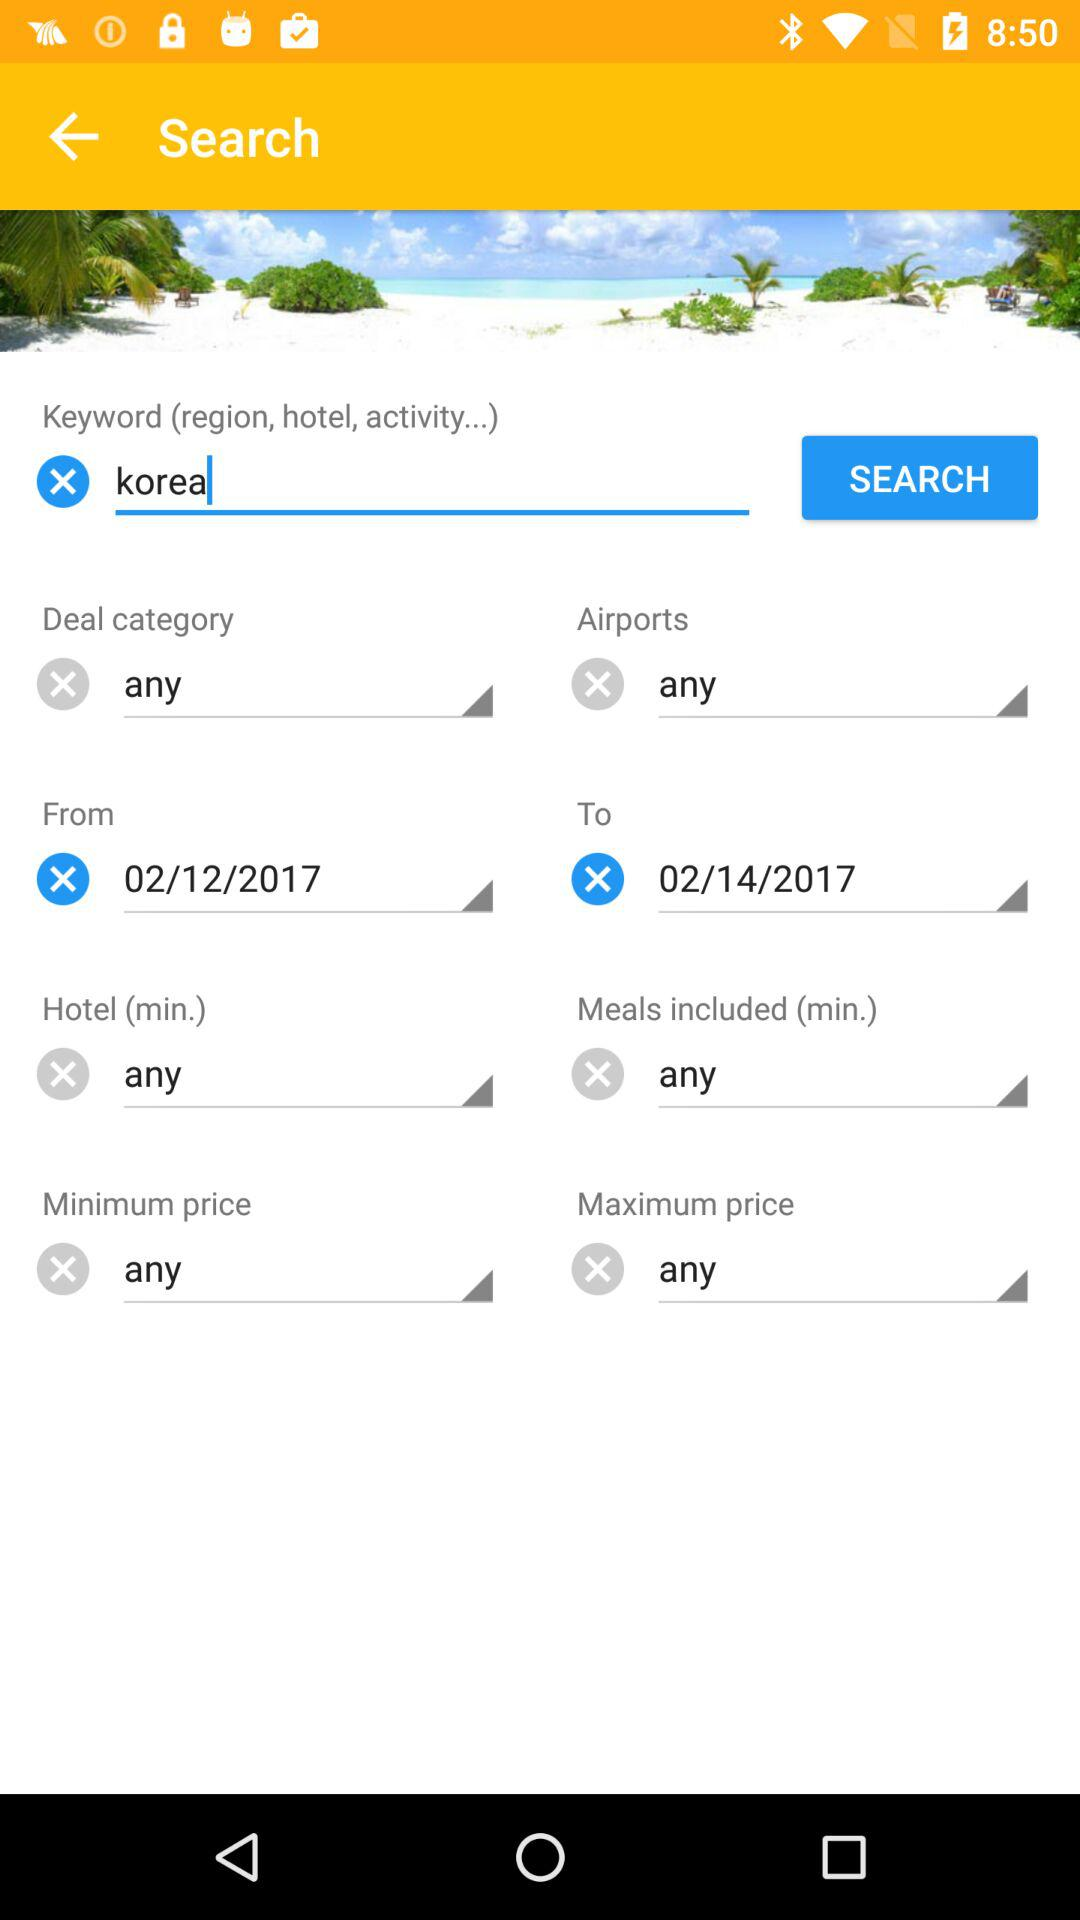How many days are there between the 'From' and 'To' dates?
Answer the question using a single word or phrase. 2 